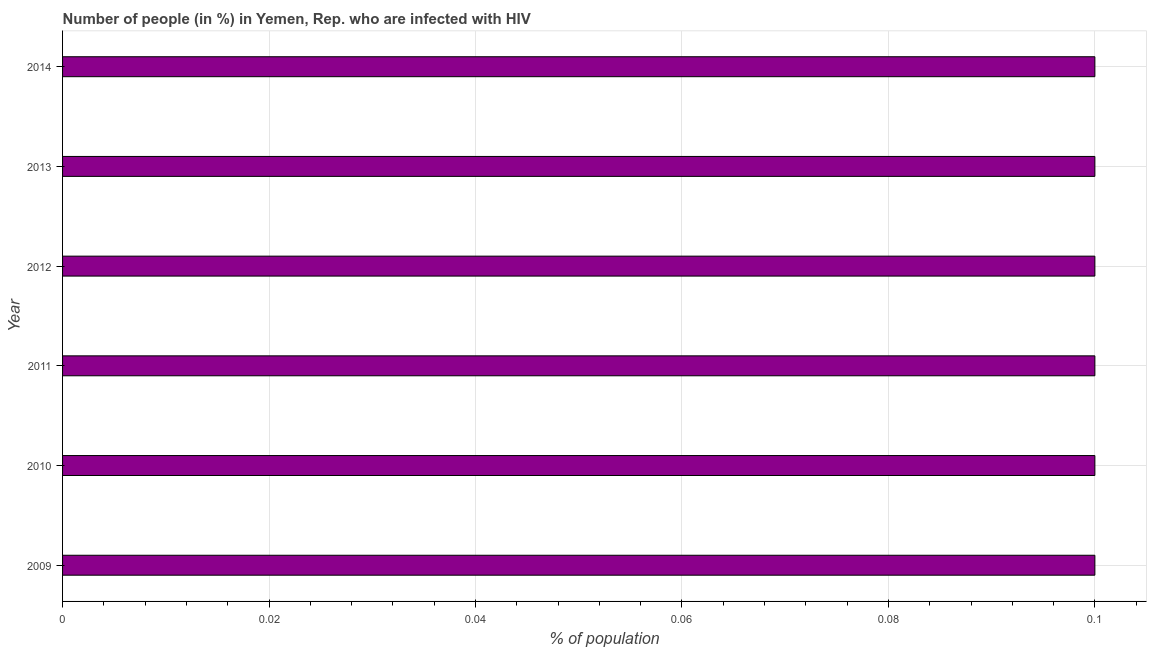Does the graph contain any zero values?
Keep it short and to the point. No. Does the graph contain grids?
Make the answer very short. Yes. What is the title of the graph?
Make the answer very short. Number of people (in %) in Yemen, Rep. who are infected with HIV. What is the label or title of the X-axis?
Give a very brief answer. % of population. Across all years, what is the maximum number of people infected with hiv?
Offer a very short reply. 0.1. Across all years, what is the minimum number of people infected with hiv?
Give a very brief answer. 0.1. In which year was the number of people infected with hiv maximum?
Make the answer very short. 2009. In which year was the number of people infected with hiv minimum?
Provide a succinct answer. 2009. What is the sum of the number of people infected with hiv?
Your response must be concise. 0.6. In how many years, is the number of people infected with hiv greater than 0.064 %?
Keep it short and to the point. 6. Is the number of people infected with hiv in 2011 less than that in 2012?
Make the answer very short. No. What is the difference between the highest and the second highest number of people infected with hiv?
Provide a short and direct response. 0. Is the sum of the number of people infected with hiv in 2011 and 2013 greater than the maximum number of people infected with hiv across all years?
Provide a succinct answer. Yes. What is the difference between the highest and the lowest number of people infected with hiv?
Offer a very short reply. 0. How many bars are there?
Ensure brevity in your answer.  6. Are the values on the major ticks of X-axis written in scientific E-notation?
Give a very brief answer. No. What is the % of population of 2011?
Give a very brief answer. 0.1. What is the difference between the % of population in 2009 and 2010?
Offer a terse response. 0. What is the difference between the % of population in 2009 and 2012?
Your answer should be very brief. 0. What is the difference between the % of population in 2009 and 2013?
Offer a very short reply. 0. What is the difference between the % of population in 2009 and 2014?
Make the answer very short. 0. What is the difference between the % of population in 2010 and 2011?
Offer a very short reply. 0. What is the difference between the % of population in 2010 and 2012?
Your response must be concise. 0. What is the difference between the % of population in 2010 and 2014?
Keep it short and to the point. 0. What is the difference between the % of population in 2011 and 2012?
Ensure brevity in your answer.  0. What is the difference between the % of population in 2012 and 2014?
Make the answer very short. 0. What is the difference between the % of population in 2013 and 2014?
Offer a terse response. 0. What is the ratio of the % of population in 2009 to that in 2010?
Keep it short and to the point. 1. What is the ratio of the % of population in 2009 to that in 2011?
Your answer should be very brief. 1. What is the ratio of the % of population in 2009 to that in 2012?
Keep it short and to the point. 1. What is the ratio of the % of population in 2009 to that in 2014?
Make the answer very short. 1. What is the ratio of the % of population in 2010 to that in 2011?
Your response must be concise. 1. What is the ratio of the % of population in 2010 to that in 2012?
Provide a succinct answer. 1. What is the ratio of the % of population in 2010 to that in 2014?
Your answer should be very brief. 1. What is the ratio of the % of population in 2011 to that in 2012?
Your answer should be compact. 1. What is the ratio of the % of population in 2012 to that in 2013?
Give a very brief answer. 1. 